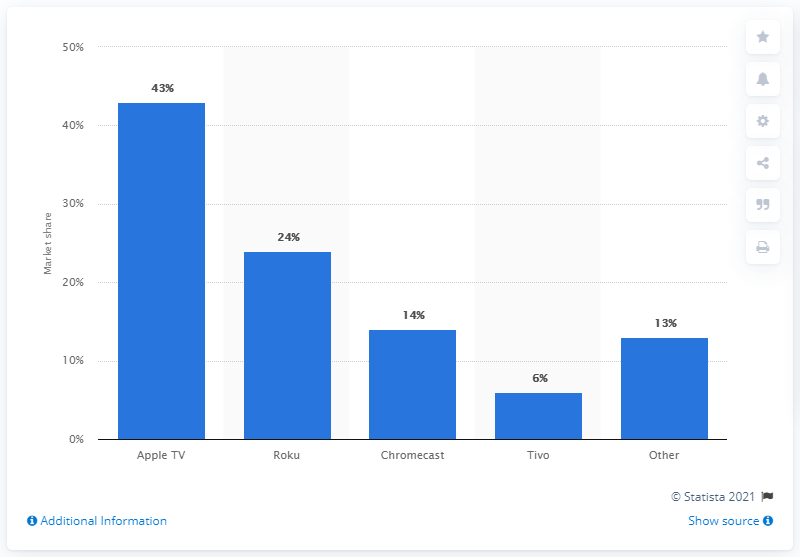Give some essential details in this illustration. In 2014, the market share of Google's Chromecast was 14.. 